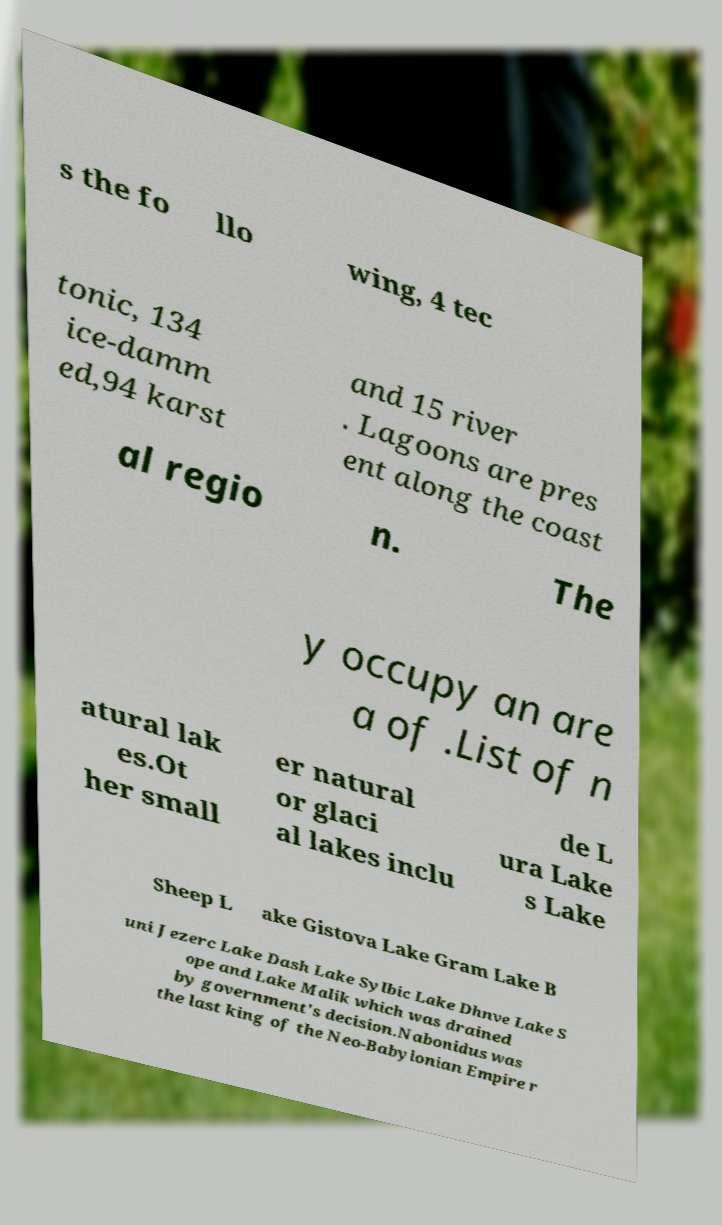Could you extract and type out the text from this image? s the fo llo wing, 4 tec tonic, 134 ice-damm ed,94 karst and 15 river . Lagoons are pres ent along the coast al regio n. The y occupy an are a of .List of n atural lak es.Ot her small er natural or glaci al lakes inclu de L ura Lake s Lake Sheep L ake Gistova Lake Gram Lake B uni Jezerc Lake Dash Lake Sylbic Lake Dhnve Lake S ope and Lake Malik which was drained by government's decision.Nabonidus was the last king of the Neo-Babylonian Empire r 